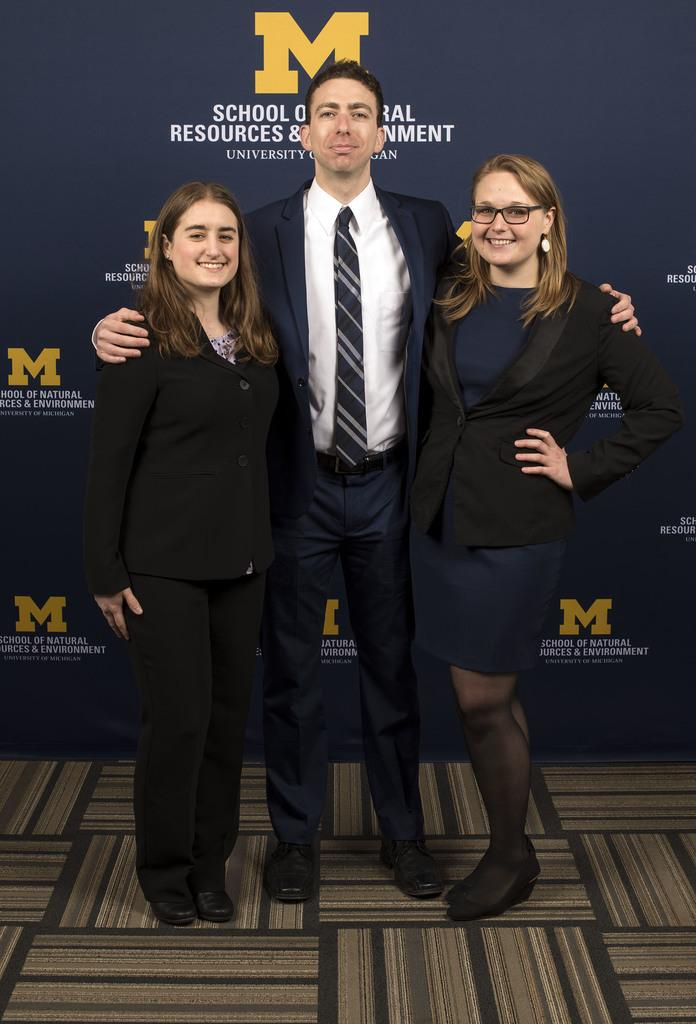How many people are in the image? There are three persons in the image. What are the persons doing in the image? The persons are standing and smiling. What can be seen in the background of the image? There is a board in the background of the image. What is visible at the bottom of the image? There is a floor visible at the bottom of the image. What type of stomach ache is the person on the left experiencing in the image? There is no indication in the image that any of the persons are experiencing a stomach ache, so it cannot be determined from the picture. 